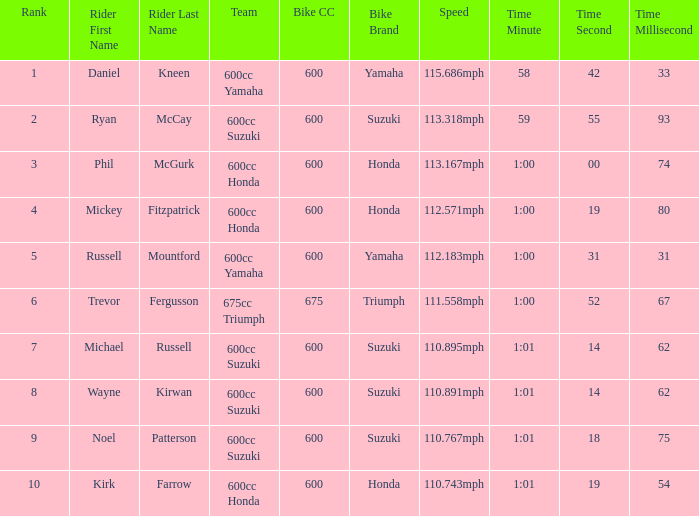What time has phil mcgurk as the rider? 1:00.00.74. 